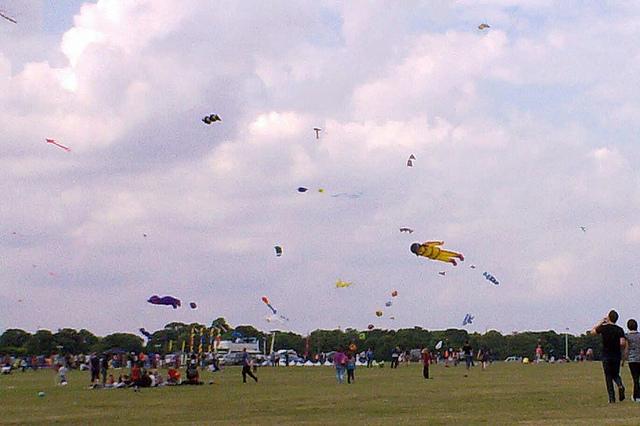What are they playing?
Write a very short answer. Kite. Where is this taken?
Give a very brief answer. Park. How many kites are in the sky?
Be succinct. Many. How many people are wearing long pants?
Quick response, please. 20. Is it a cloudy day?
Give a very brief answer. Yes. Does this look like an open field?
Answer briefly. Yes. Where was the picture taken?
Keep it brief. Park. Is the sky clear?
Answer briefly. No. How many kites are there?
Short answer required. Many. Is the ground flat or hilly?
Be succinct. Flat. What color is the kite to the left?
Write a very short answer. Blue. Are there a lot of kites in the air?
Quick response, please. Yes. Which kite resembles a human body?
Quick response, please. Yellow one. 